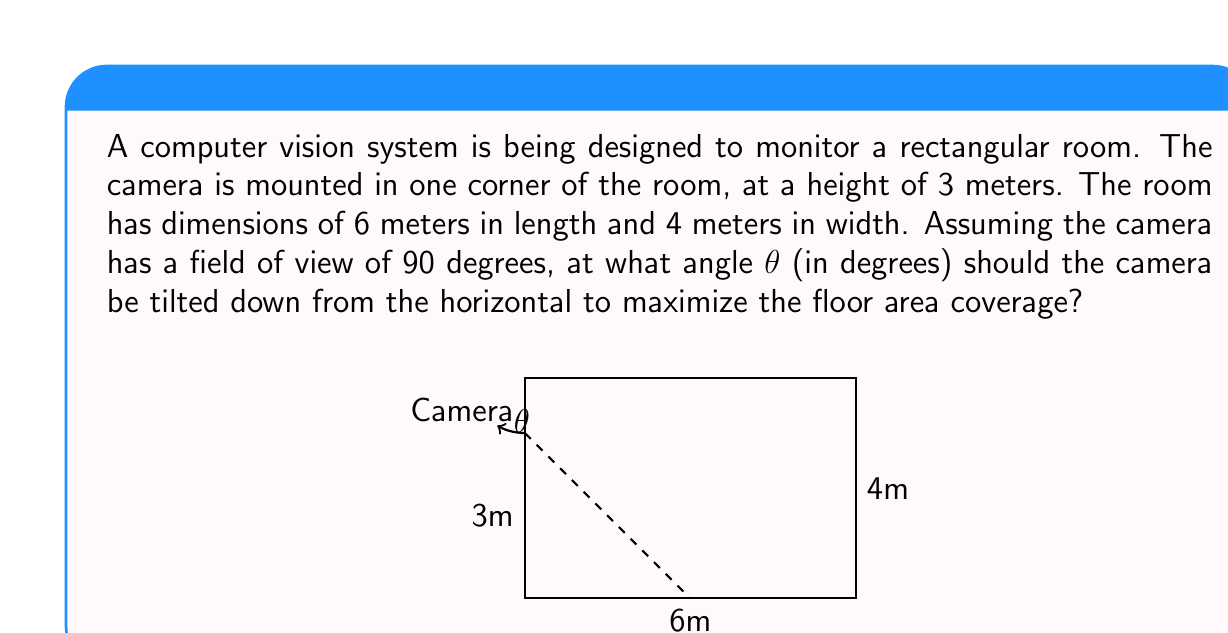Teach me how to tackle this problem. To solve this problem, we need to consider the geometry of the room and the camera's field of view. Let's approach this step-by-step:

1) First, we need to find the angle that covers the entire floor diagonally. This will be our reference point.

2) The diagonal of the room can be calculated using the Pythagorean theorem:
   $$d = \sqrt{6^2 + 4^2} = \sqrt{52} \approx 7.21 \text{ meters}$$

3) Now, we can calculate the angle from the camera to the far corner of the room:
   $$\alpha = \arctan(\frac{d}{3}) = \arctan(\frac{7.21}{3}) \approx 67.38°$$

4) The optimal angle would be half of this angle, as it would place the center of the camera's field of view at the center of the floor:
   $$\theta = \frac{\alpha}{2} \approx 33.69°$$

5) However, we need to verify if this angle allows for full coverage of the near edge of the room. The camera's field of view is 90°, so the angle to the near edge should be no more than 45° from the center line.

6) We can calculate this angle:
   $$\beta = \arctan(\frac{4}{3}) \approx 53.13°$$

7) The angle from the center line to the near edge is:
   $$\frac{\beta}{2} \approx 26.57°$$

8) Since 26.57° < 45°, our calculated optimal angle of 33.69° is valid and will provide maximum coverage.
Answer: The optimal angle θ for maximum floor coverage is approximately 33.69°. 